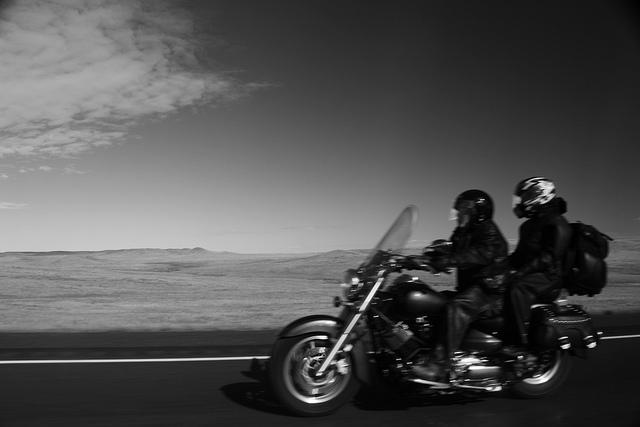Is the motorcycle in motion?
Concise answer only. Yes. Does this motorcycle have a windshield?
Quick response, please. Yes. Are they riding along a coastline?
Concise answer only. No. What are they doing with the bike?
Write a very short answer. Riding. Is the picture black and white?
Short answer required. Yes. What is on the back on the motorcycle?
Write a very short answer. Person. Can you see the biker's faces?
Concise answer only. No. 